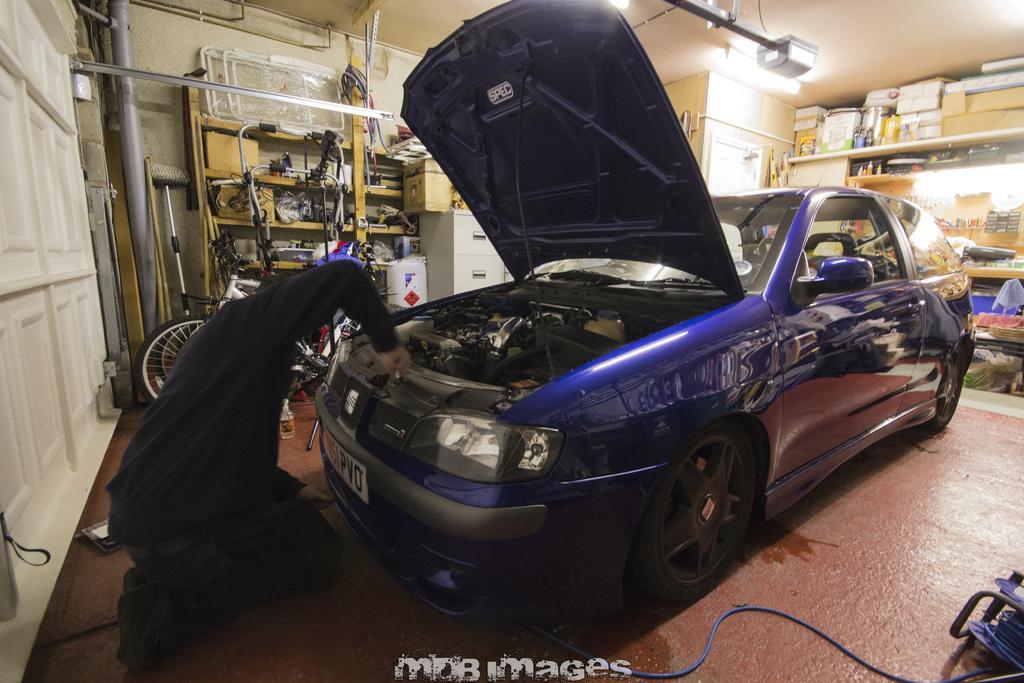Describe this image in one or two sentences. In this picture we can observe a blue color car parked on the floor. There is a person in front of the car, wearing black color dress and sitting on the floor. We can observe a garage. There is a white color cupboard here. On the right side there are some boxes placed in the shelf. 